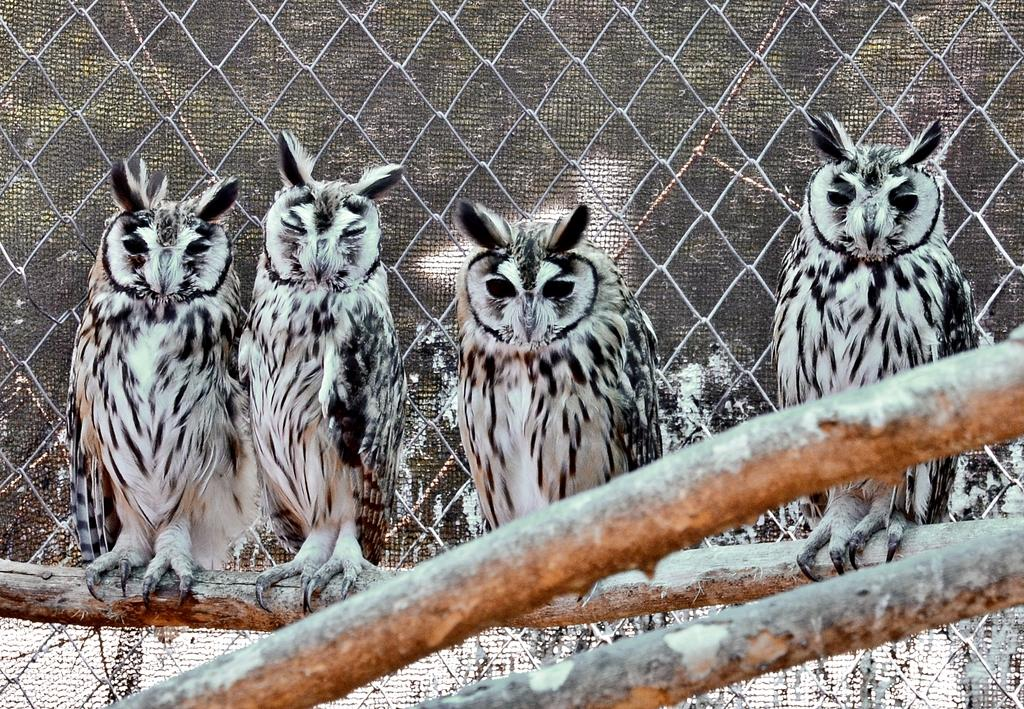What types of living organisms can be seen in the foreground of the image? There are animals in the foreground of the image. What objects are located at the bottom of the image? There are wooden sticks at the bottom of the image. What type of structure can be seen in the background of the image? There is a fence in the background of the image. What type of metal is the sister using to stretch in the image? There is no sister or metal present in the image. 